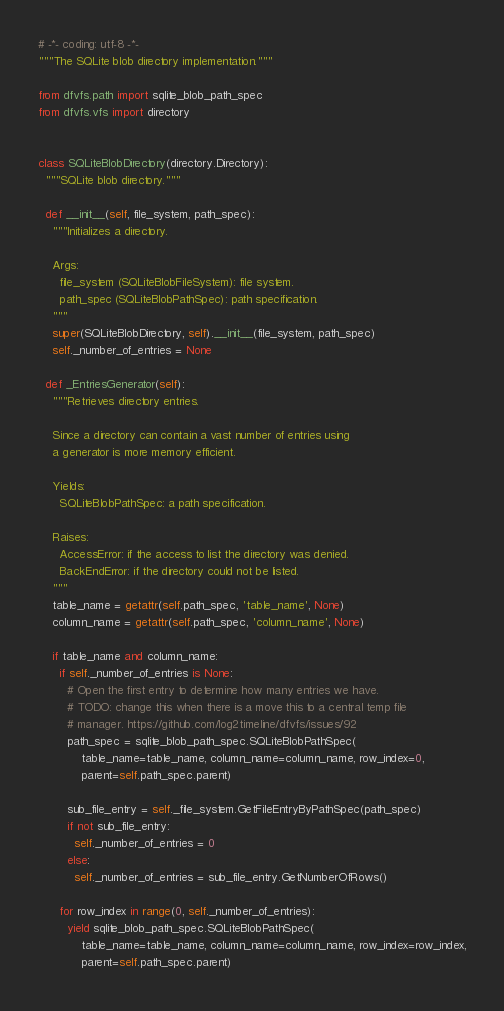<code> <loc_0><loc_0><loc_500><loc_500><_Python_># -*- coding: utf-8 -*-
"""The SQLite blob directory implementation."""

from dfvfs.path import sqlite_blob_path_spec
from dfvfs.vfs import directory


class SQLiteBlobDirectory(directory.Directory):
  """SQLite blob directory."""

  def __init__(self, file_system, path_spec):
    """Initializes a directory.

    Args:
      file_system (SQLiteBlobFileSystem): file system.
      path_spec (SQLiteBlobPathSpec): path specification.
    """
    super(SQLiteBlobDirectory, self).__init__(file_system, path_spec)
    self._number_of_entries = None

  def _EntriesGenerator(self):
    """Retrieves directory entries.

    Since a directory can contain a vast number of entries using
    a generator is more memory efficient.

    Yields:
      SQLiteBlobPathSpec: a path specification.

    Raises:
      AccessError: if the access to list the directory was denied.
      BackEndError: if the directory could not be listed.
    """
    table_name = getattr(self.path_spec, 'table_name', None)
    column_name = getattr(self.path_spec, 'column_name', None)

    if table_name and column_name:
      if self._number_of_entries is None:
        # Open the first entry to determine how many entries we have.
        # TODO: change this when there is a move this to a central temp file
        # manager. https://github.com/log2timeline/dfvfs/issues/92
        path_spec = sqlite_blob_path_spec.SQLiteBlobPathSpec(
            table_name=table_name, column_name=column_name, row_index=0,
            parent=self.path_spec.parent)

        sub_file_entry = self._file_system.GetFileEntryByPathSpec(path_spec)
        if not sub_file_entry:
          self._number_of_entries = 0
        else:
          self._number_of_entries = sub_file_entry.GetNumberOfRows()

      for row_index in range(0, self._number_of_entries):
        yield sqlite_blob_path_spec.SQLiteBlobPathSpec(
            table_name=table_name, column_name=column_name, row_index=row_index,
            parent=self.path_spec.parent)
</code> 